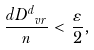Convert formula to latex. <formula><loc_0><loc_0><loc_500><loc_500>\frac { d D _ { \ v r } ^ { d } } { n } < \frac { \varepsilon } { 2 } ,</formula> 